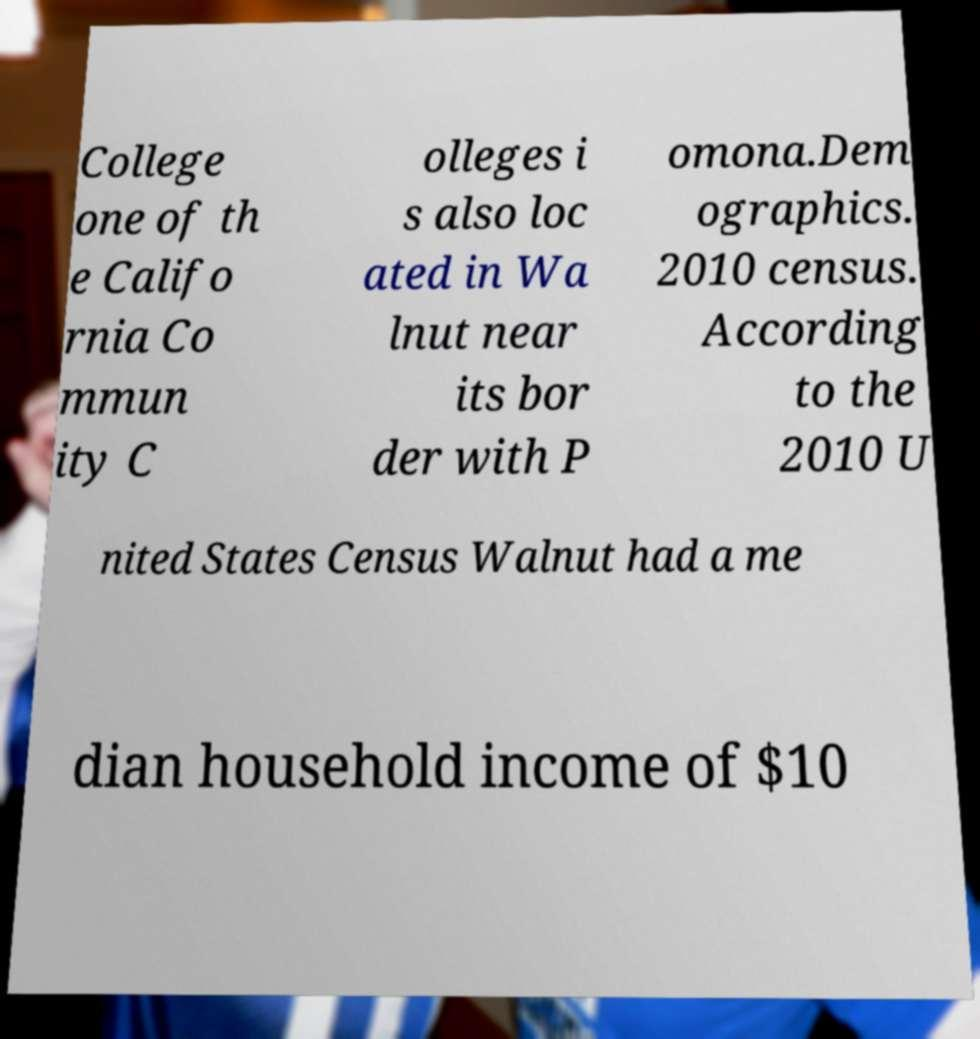Please identify and transcribe the text found in this image. College one of th e Califo rnia Co mmun ity C olleges i s also loc ated in Wa lnut near its bor der with P omona.Dem ographics. 2010 census. According to the 2010 U nited States Census Walnut had a me dian household income of $10 